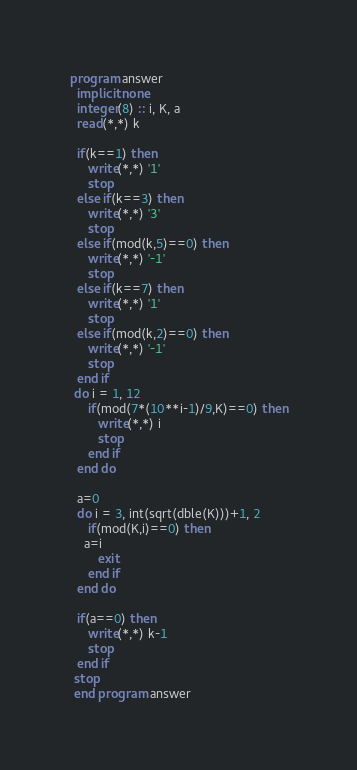Convert code to text. <code><loc_0><loc_0><loc_500><loc_500><_FORTRAN_>program answer
  implicit none
  integer(8) :: i, K, a
  read(*,*) k

  if(k==1) then
     write(*,*) '1'
     stop
  else if(k==3) then
     write(*,*) '3'
     stop
  else if(mod(k,5)==0) then
     write(*,*) '-1'
     stop
  else if(k==7) then
     write(*,*) '1'
     stop
  else if(mod(k,2)==0) then
     write(*,*) '-1'
     stop
  end if
 do i = 1, 12
     if(mod(7*(10**i-1)/9,K)==0) then
        write(*,*) i
        stop
     end if
  end do

  a=0
  do i = 3, int(sqrt(dble(K)))+1, 2
     if(mod(K,i)==0) then
	a=i
        exit
     end if
  end do

  if(a==0) then
     write(*,*) k-1
     stop
  end if
 stop
 end program answer
</code> 